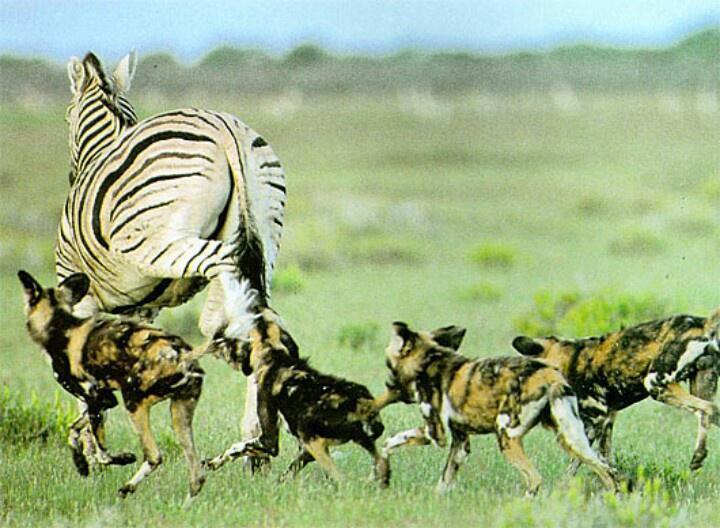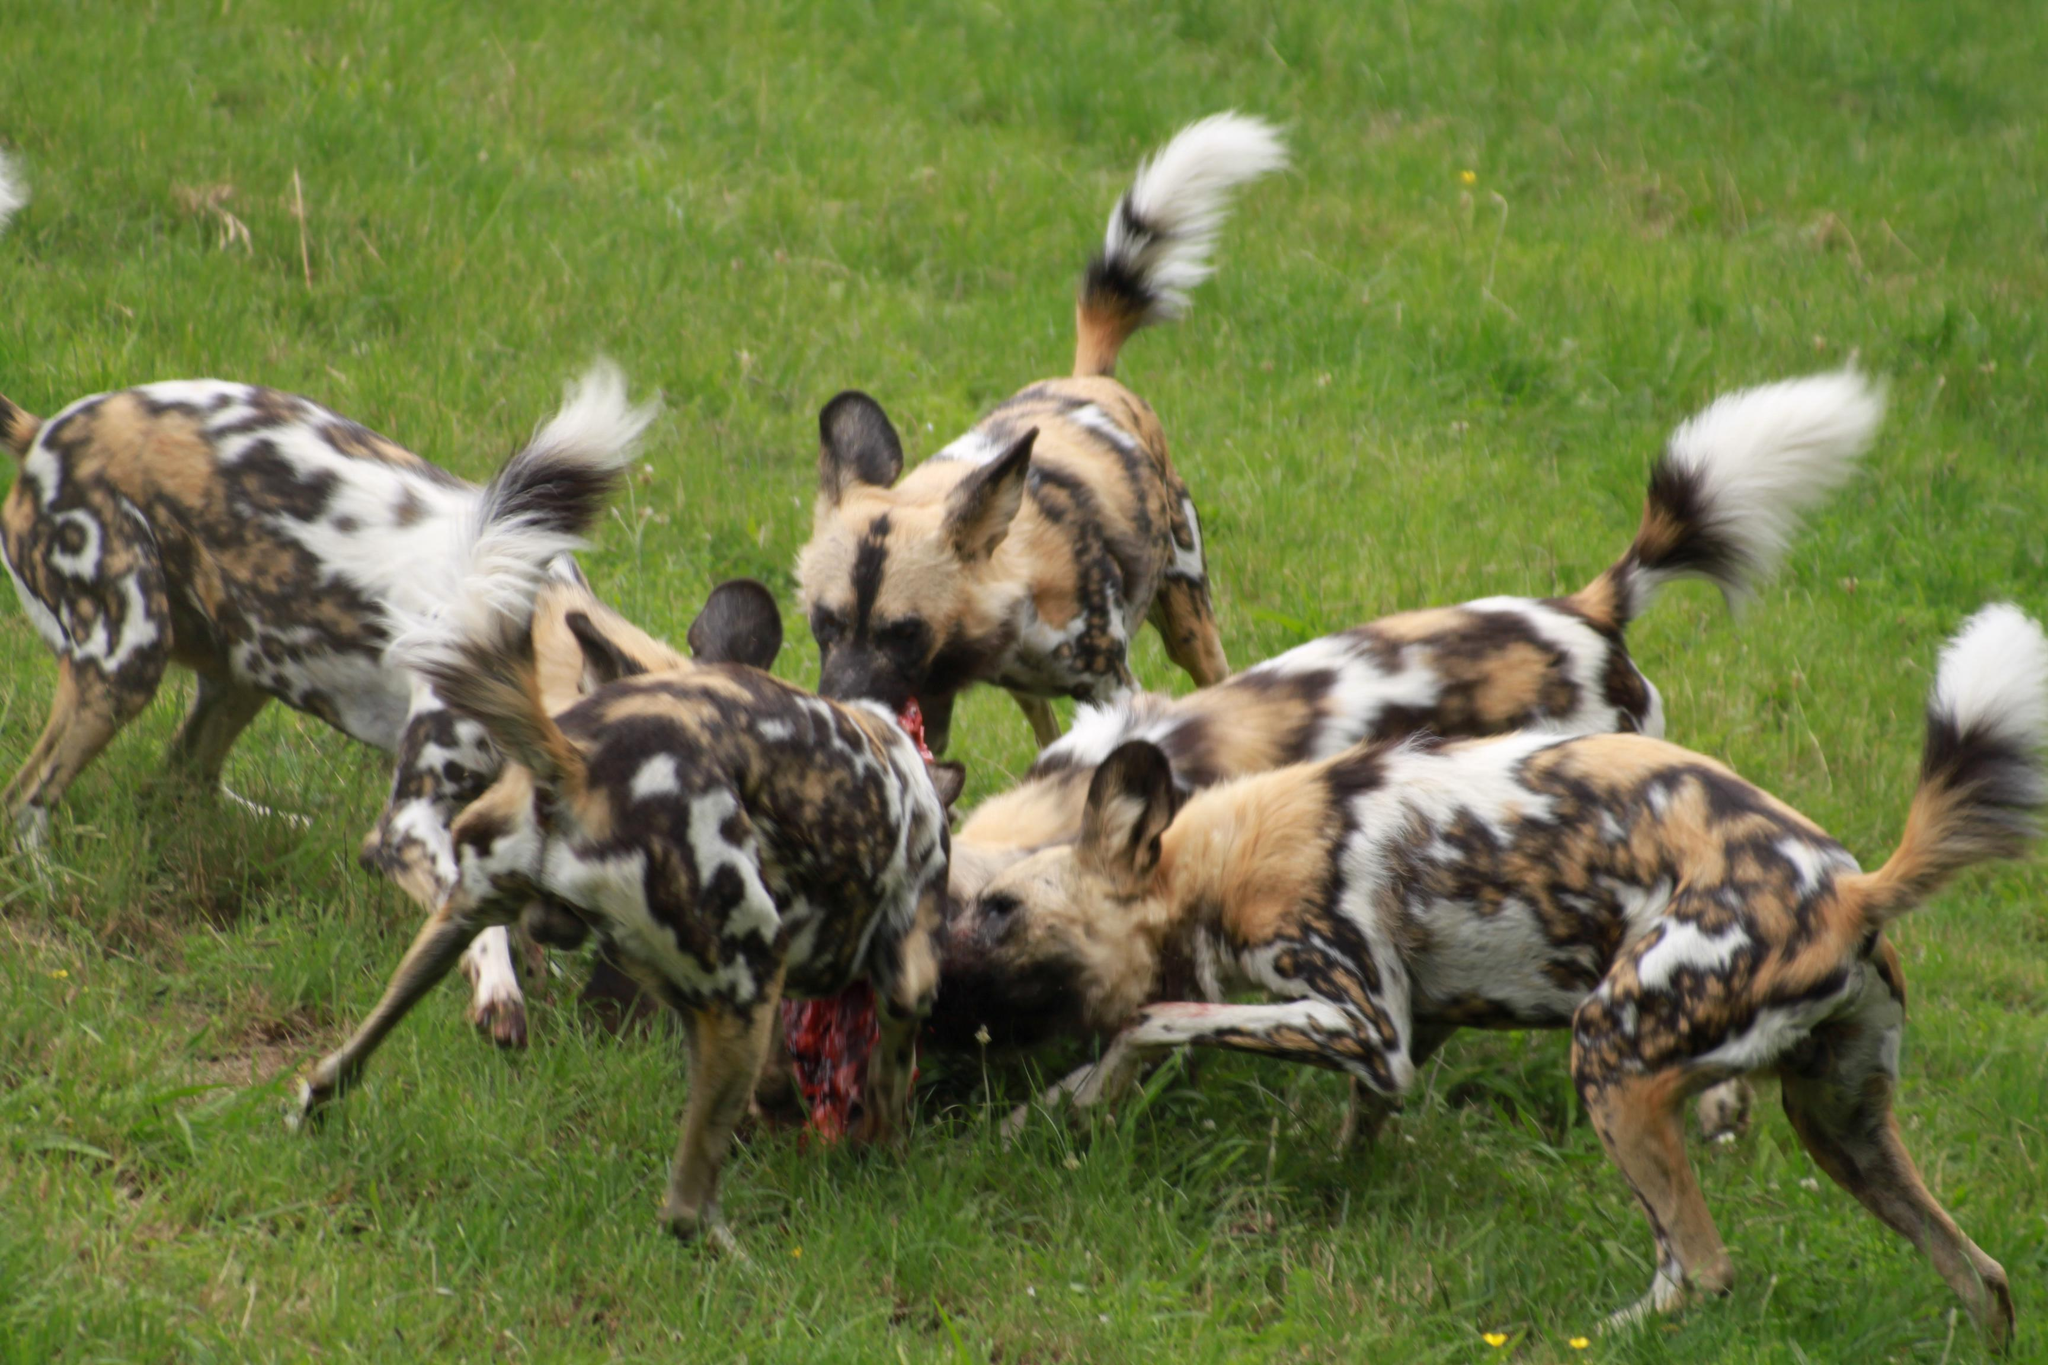The first image is the image on the left, the second image is the image on the right. For the images shown, is this caption "One image shows hyenas around an open-mouthed lion." true? Answer yes or no. No. 